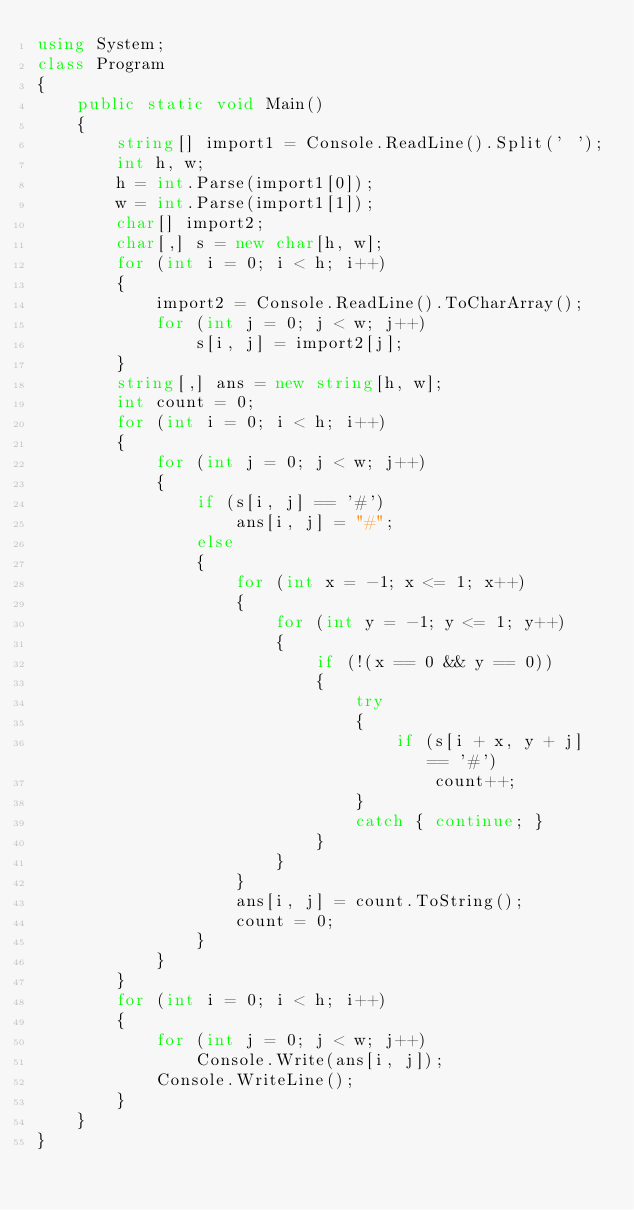Convert code to text. <code><loc_0><loc_0><loc_500><loc_500><_C#_>using System;
class Program
{
    public static void Main()
    {
        string[] import1 = Console.ReadLine().Split(' ');
        int h, w;
        h = int.Parse(import1[0]);
        w = int.Parse(import1[1]);
        char[] import2;
        char[,] s = new char[h, w];
        for (int i = 0; i < h; i++)
        {
            import2 = Console.ReadLine().ToCharArray();
            for (int j = 0; j < w; j++)
                s[i, j] = import2[j];
        }
        string[,] ans = new string[h, w];
        int count = 0;
        for (int i = 0; i < h; i++)
        {
            for (int j = 0; j < w; j++)
            {
                if (s[i, j] == '#')
                    ans[i, j] = "#";
                else
                {
                    for (int x = -1; x <= 1; x++)
                    {
                        for (int y = -1; y <= 1; y++)
                        {
                            if (!(x == 0 && y == 0))
                            {
                                try
                                {
                                    if (s[i + x, y + j] == '#')
                                        count++;
                                }
                                catch { continue; }
                            }
                        }
                    }
                    ans[i, j] = count.ToString();
                    count = 0;
                }
            }
        }
        for (int i = 0; i < h; i++)
        {
            for (int j = 0; j < w; j++)
                Console.Write(ans[i, j]);
            Console.WriteLine();
        }
    }
}</code> 